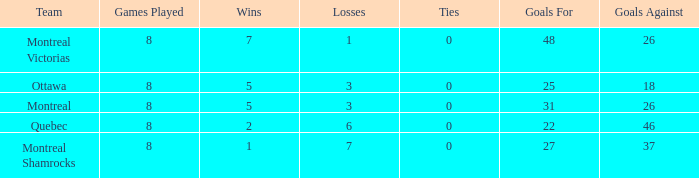For the team with 22 goals scored and more than 8 games played, how many losses did they experience? 0.0. 